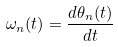Convert formula to latex. <formula><loc_0><loc_0><loc_500><loc_500>\omega _ { n } ( t ) = \frac { d \theta _ { n } ( t ) } { d t }</formula> 